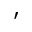Convert formula to latex. <formula><loc_0><loc_0><loc_500><loc_500>^ { \prime }</formula> 